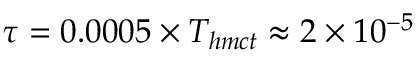Convert formula to latex. <formula><loc_0><loc_0><loc_500><loc_500>\tau = 0 . 0 0 0 5 \times T _ { h m c t } \approx 2 \times 1 0 ^ { - 5 }</formula> 